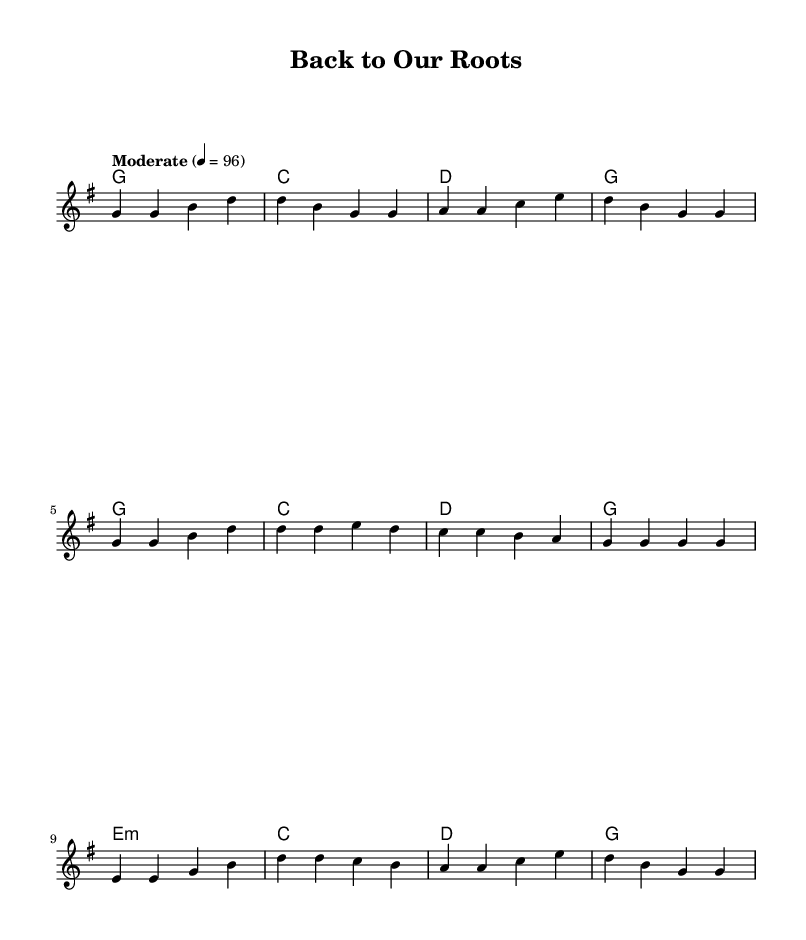What is the key signature of this music? The key signature is G major, which has one sharp (F#).
Answer: G major What is the time signature of this music? The time signature is 4/4, indicating four beats per measure.
Answer: 4/4 What is the tempo marking indicated in the music? The tempo marking is "Moderate" with a metronome marking of 96 beats per minute.
Answer: Moderate, 96 How many measures are in the verse section? There are four measures in the verse section as indicated by the melody line.
Answer: 4 What is the emotional theme conveyed in the chorus lyrics? The chorus conveys themes of family, faith, and belonging, emphasizing traditional values.
Answer: Family, faith, belonging Which musical section includes the line "Some may say we're old-fashioned"? This line is part of the bridge section, indicating a shift in the message of the song.
Answer: Bridge What is the harmonic progression for the verse? The harmonic progression for the verse follows G, C, D, G.
Answer: G, C, D, G 